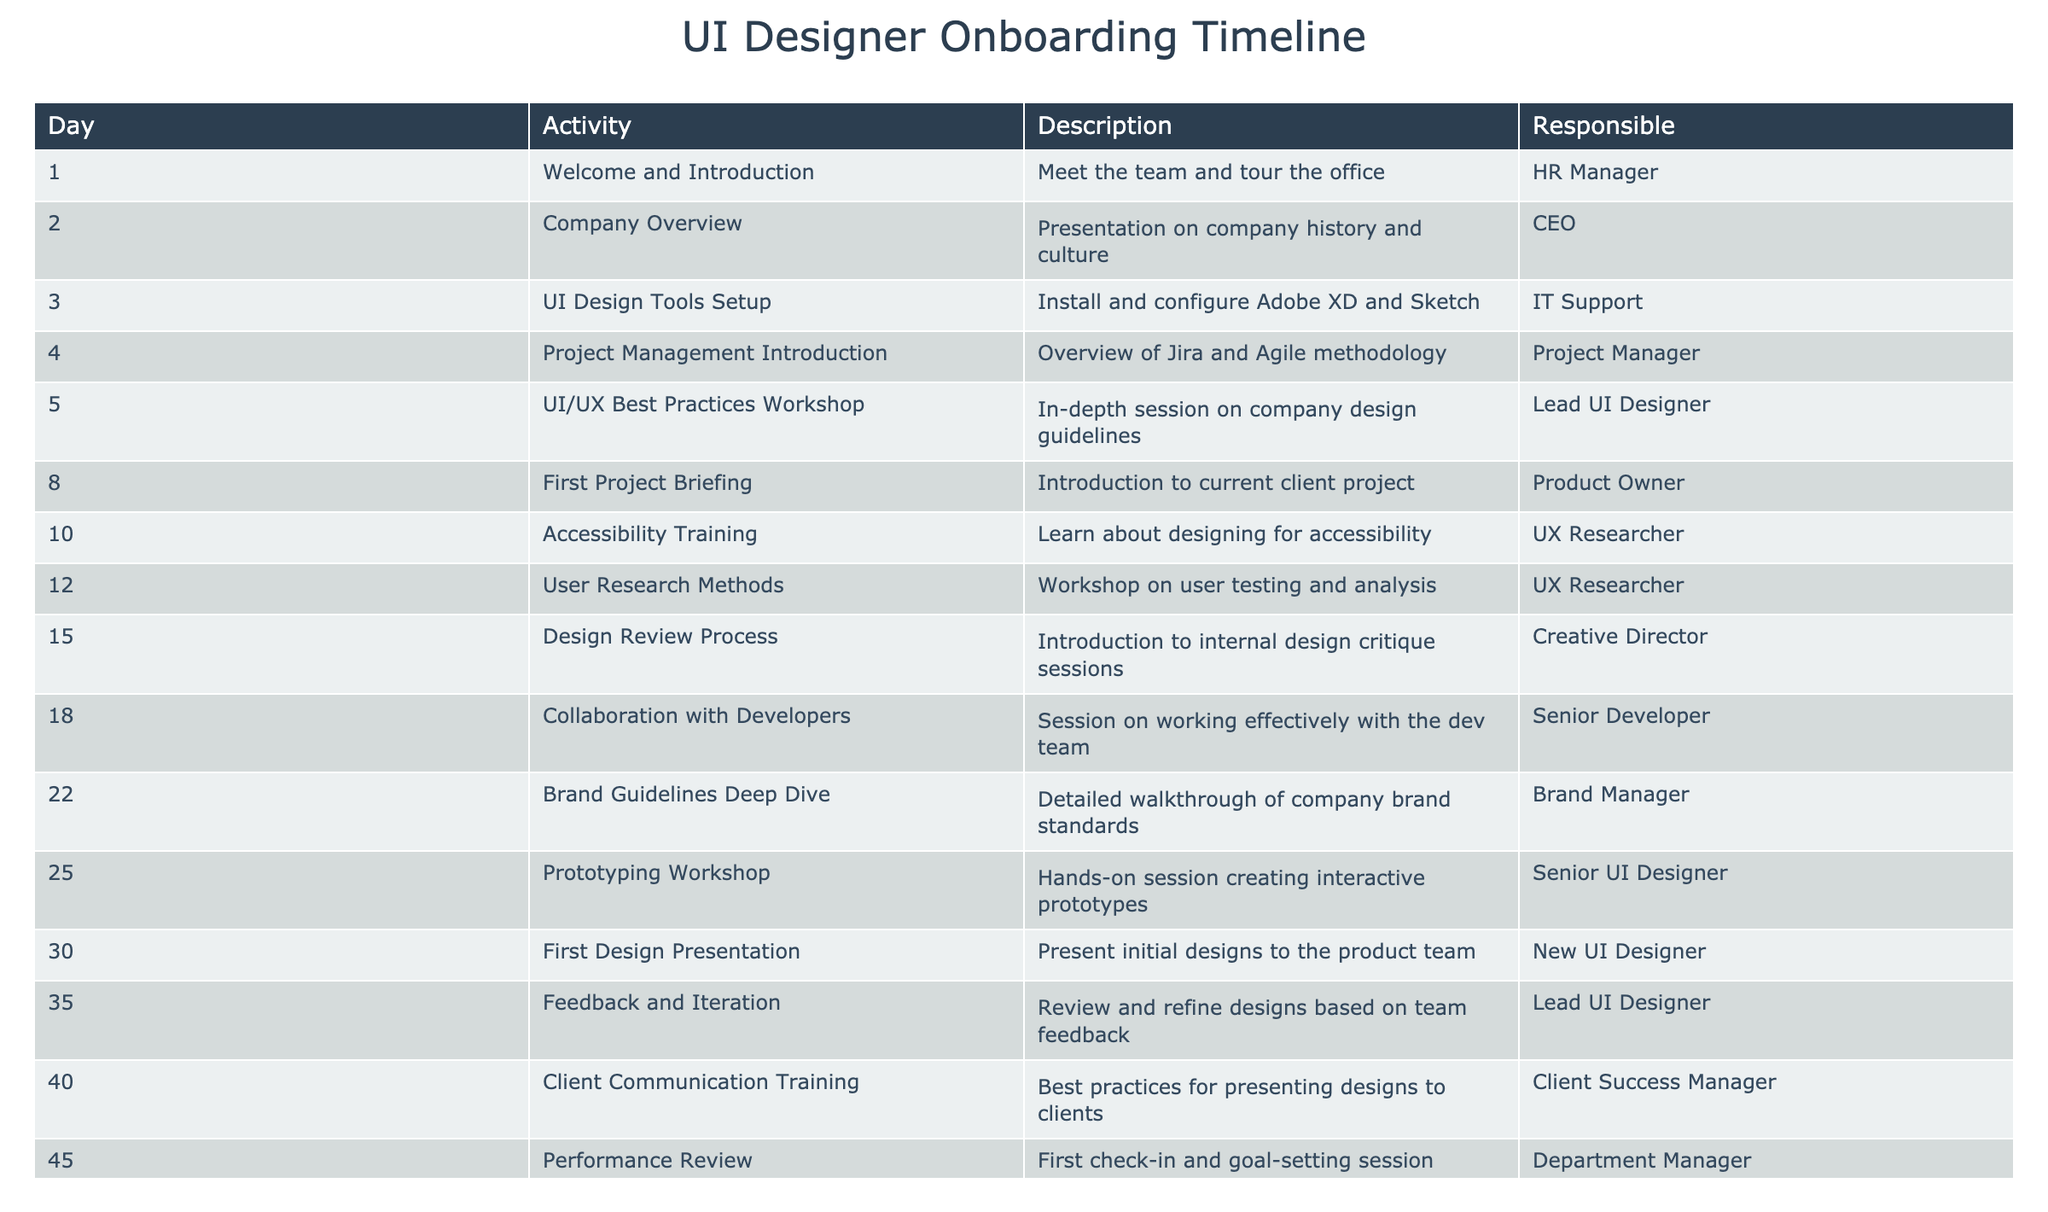What is the activity scheduled on Day 5? Referring to the table, we look for the row where the "Day" column has the value 5. The corresponding "Activity" in that row is "UI/UX Best Practices Workshop."
Answer: UI/UX Best Practices Workshop Who is responsible for the "Collaboration with Developers" session? The activity "Collaboration with Developers" is on Day 18. By checking the table, we see that the "Responsible" person for this session is the "Senior Developer."
Answer: Senior Developer How many days are scheduled between the "First Project Briefing" and the "First Design Presentation"? The "First Project Briefing" is scheduled for Day 8, and the "First Design Presentation" is on Day 30. To find the number of days between them, we subtract 8 from 30: 30 - 8 = 22 days.
Answer: 22 Is there an accessibility training workshop in the onboarding schedule? Yes, there is a training session titled "Accessibility Training" scheduled on Day 10. By looking in the table, we confirm its presence.
Answer: Yes What is the total number of training sessions listed in the schedule? We can count the "Description" entries in the table. Each unique activity described represents a training or workshop session. There are 12 sessions listed, hence the total is 12.
Answer: 12 Which activities are scheduled in the last week of the onboarding program? The last week starts on Day 40 and goes to Day 45. In that period, the activities listed are "Client Communication Training" on Day 40 and "Performance Review" on Day 45.
Answer: Client Communication Training, Performance Review Who conducts the workshop on "User Research Methods"? Looking at the table, "User Research Methods" is scheduled on Day 12. The "Responsible" person for this workshop is the "UX Researcher."
Answer: UX Researcher How many sessions are conducted by the Lead UI Designer? By scanning the table, we find two sessions where the "Responsible" is listed as the "Lead UI Designer": the "UI/UX Best Practices Workshop" and "Feedback and Iteration." Thus, there are 2 sessions.
Answer: 2 What day is allocated for the “Brand Guidelines Deep Dive” session, and who is responsible for it? The "Brand Guidelines Deep Dive" session is on Day 22. The person responsible for this session is the "Brand Manager," as indicated in the table.
Answer: Day 22, Brand Manager 